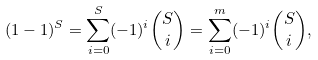Convert formula to latex. <formula><loc_0><loc_0><loc_500><loc_500>( 1 - 1 ) ^ { S } = \sum _ { i = 0 } ^ { S } ( - 1 ) ^ { i } { S \choose i } = \sum _ { i = 0 } ^ { m } ( - 1 ) ^ { i } { S \choose i } ,</formula> 